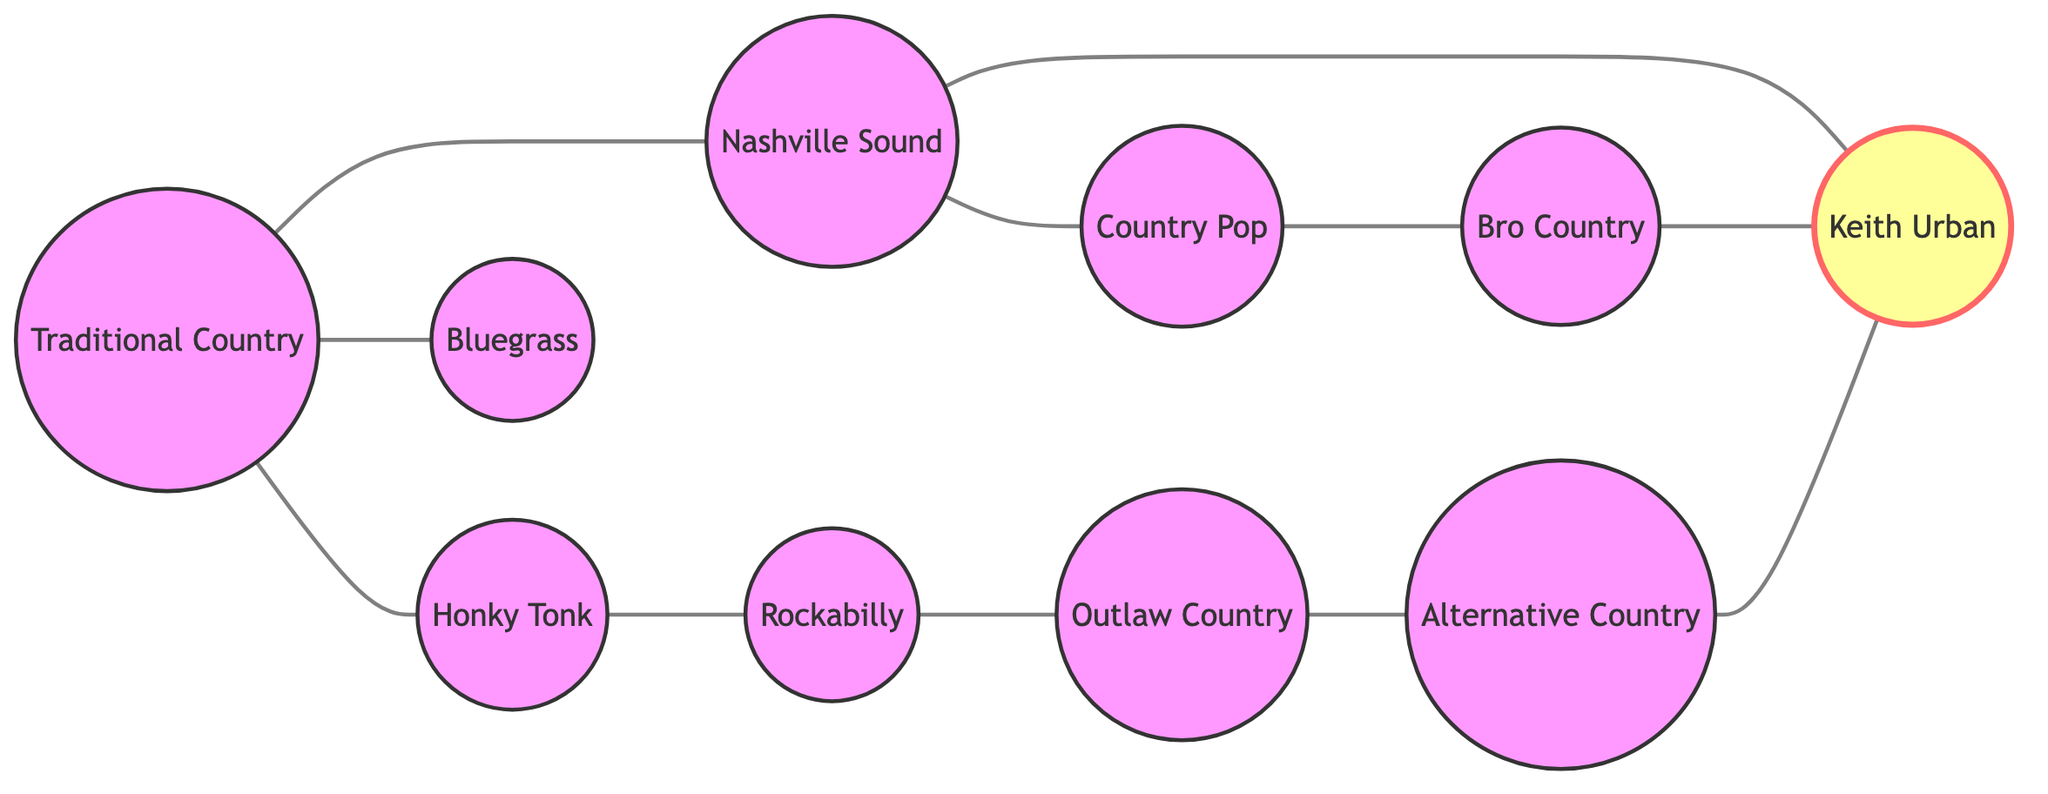What are the total nodes in the diagram? The diagram contains 10 unique nodes representing various country music genres and artists. I counted all the distinct nodes displayed.
Answer: 10 Which genre is directly linked to both Honky Tonk and Traditional Country? The genre directly linked to both Honky Tonk and Traditional Country is Bluegrass. By examining the edges, I see Bluegrass connected to Traditional Country and also linked to Honky Tonk indirectly.
Answer: Bluegrass What genre is a direct descendant of Nashville Sound? Country Pop is a direct descendant of Nashville Sound, as indicated by the edge connecting the two nodes.
Answer: Country Pop How many genres are connected to Keith Urban? Keith Urban is connected to three genres: Nashville Sound, Bro Country, and Alternative Country. I counted the edges leading to Keith Urban from these three genres.
Answer: 3 Which genre has the most connections to other genres? Traditional Country has the most connections with three direct links: to Honky Tonk, Bluegrass, and Nashville Sound. After evaluating all node connections, Traditional Country has the highest degree of connections.
Answer: Traditional Country Which genres are considered sub-genres of Outlaw Country? Alternative Country is the sub-genre of Outlaw Country, based on the directed edge between them. The graph shows a direct connection from Outlaw Country to Alternative Country indicating this relationship.
Answer: Alternative Country What is the relationship between Bro Country and Keith Urban? Bro Country has a direct connection to Keith Urban, as evidenced by the edge that directly links the two nodes.
Answer: Direct connection Which genre emerged from Rockabilly? Outlaw Country emerged from Rockabilly, indicated by the direct connection (edge) between these two genres.
Answer: Outlaw Country 